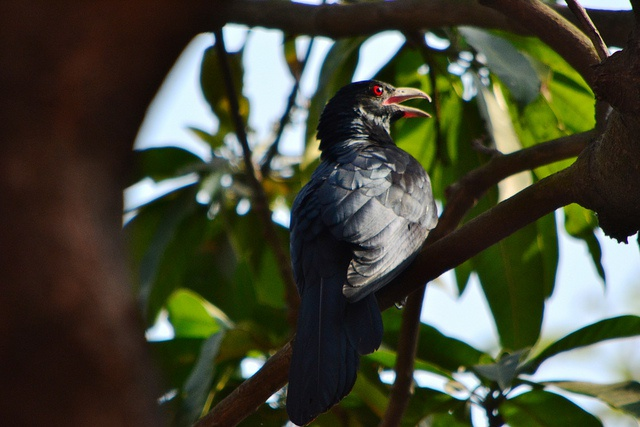Describe the objects in this image and their specific colors. I can see a bird in black, darkgray, gray, and navy tones in this image. 